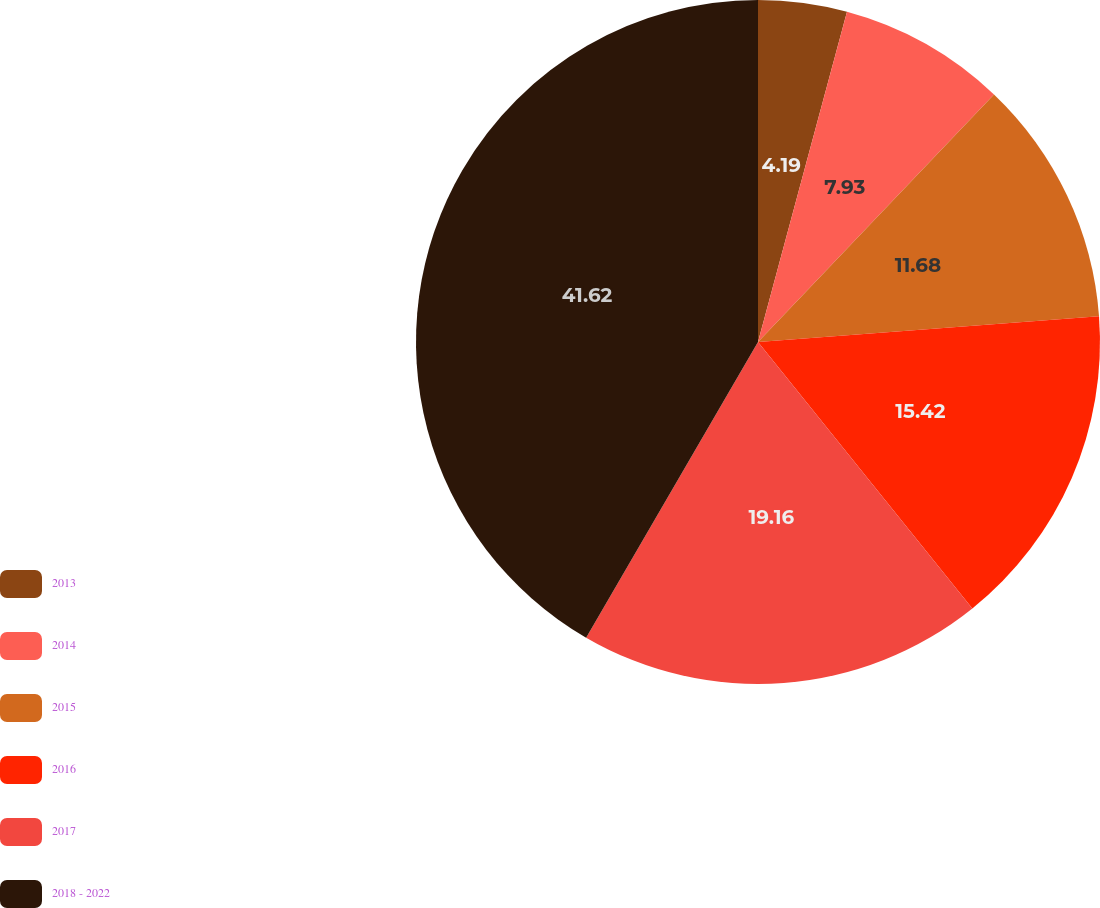Convert chart to OTSL. <chart><loc_0><loc_0><loc_500><loc_500><pie_chart><fcel>2013<fcel>2014<fcel>2015<fcel>2016<fcel>2017<fcel>2018 - 2022<nl><fcel>4.19%<fcel>7.93%<fcel>11.68%<fcel>15.42%<fcel>19.16%<fcel>41.62%<nl></chart> 